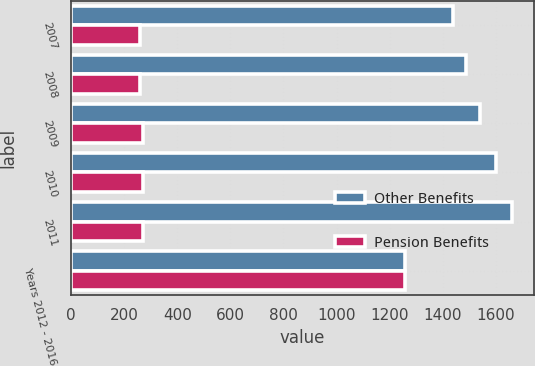Convert chart. <chart><loc_0><loc_0><loc_500><loc_500><stacked_bar_chart><ecel><fcel>2007<fcel>2008<fcel>2009<fcel>2010<fcel>2011<fcel>Years 2012 - 2016<nl><fcel>Other Benefits<fcel>1440<fcel>1490<fcel>1540<fcel>1600<fcel>1660<fcel>1260<nl><fcel>Pension Benefits<fcel>260<fcel>260<fcel>270<fcel>270<fcel>270<fcel>1260<nl></chart> 